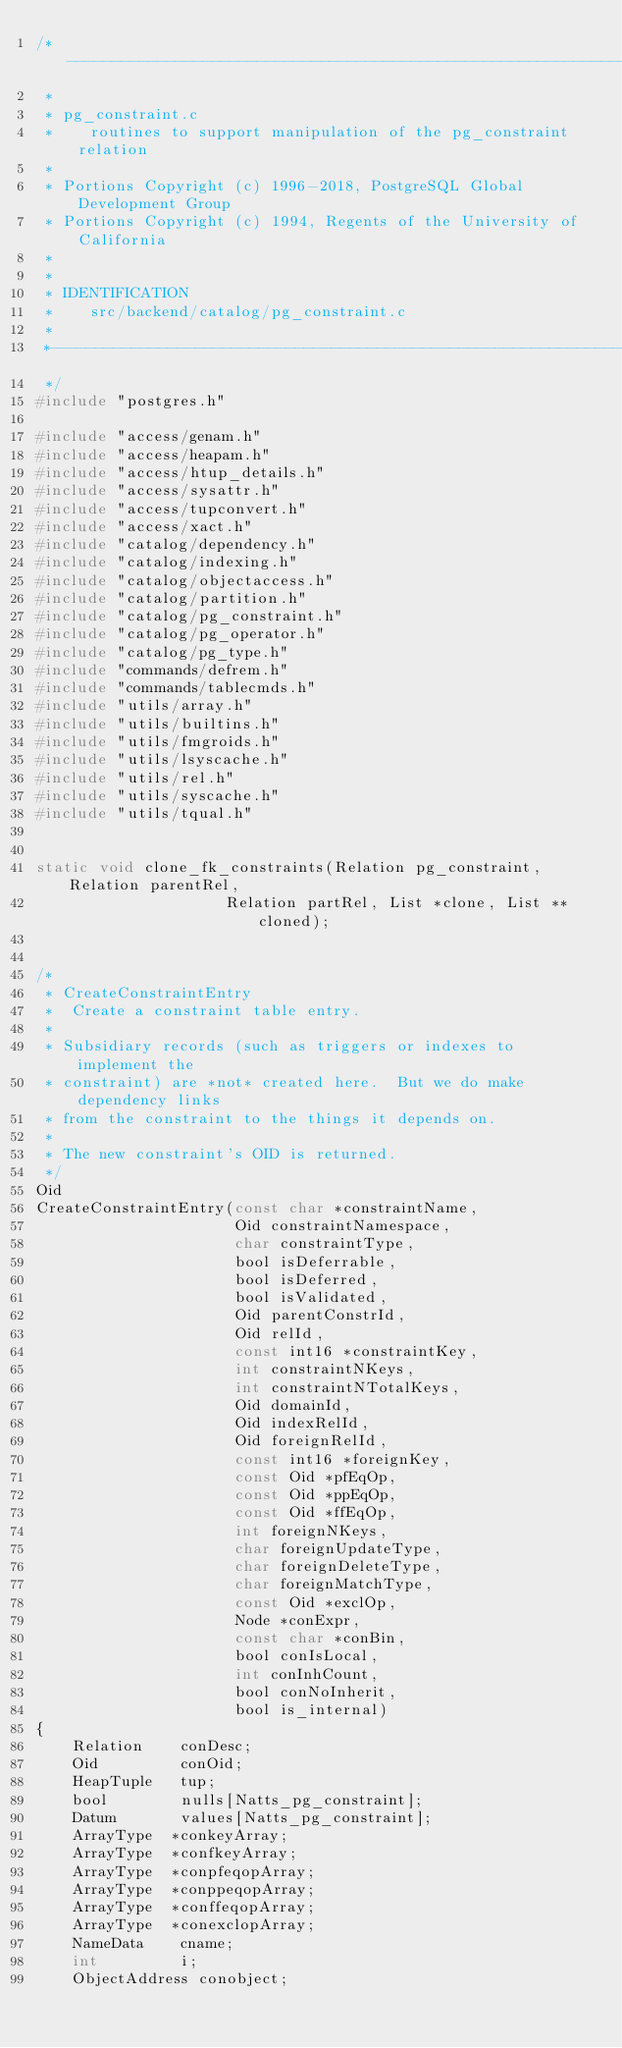<code> <loc_0><loc_0><loc_500><loc_500><_C_>/*-------------------------------------------------------------------------
 *
 * pg_constraint.c
 *	  routines to support manipulation of the pg_constraint relation
 *
 * Portions Copyright (c) 1996-2018, PostgreSQL Global Development Group
 * Portions Copyright (c) 1994, Regents of the University of California
 *
 *
 * IDENTIFICATION
 *	  src/backend/catalog/pg_constraint.c
 *
 *-------------------------------------------------------------------------
 */
#include "postgres.h"

#include "access/genam.h"
#include "access/heapam.h"
#include "access/htup_details.h"
#include "access/sysattr.h"
#include "access/tupconvert.h"
#include "access/xact.h"
#include "catalog/dependency.h"
#include "catalog/indexing.h"
#include "catalog/objectaccess.h"
#include "catalog/partition.h"
#include "catalog/pg_constraint.h"
#include "catalog/pg_operator.h"
#include "catalog/pg_type.h"
#include "commands/defrem.h"
#include "commands/tablecmds.h"
#include "utils/array.h"
#include "utils/builtins.h"
#include "utils/fmgroids.h"
#include "utils/lsyscache.h"
#include "utils/rel.h"
#include "utils/syscache.h"
#include "utils/tqual.h"


static void clone_fk_constraints(Relation pg_constraint, Relation parentRel,
					 Relation partRel, List *clone, List **cloned);


/*
 * CreateConstraintEntry
 *	Create a constraint table entry.
 *
 * Subsidiary records (such as triggers or indexes to implement the
 * constraint) are *not* created here.  But we do make dependency links
 * from the constraint to the things it depends on.
 *
 * The new constraint's OID is returned.
 */
Oid
CreateConstraintEntry(const char *constraintName,
					  Oid constraintNamespace,
					  char constraintType,
					  bool isDeferrable,
					  bool isDeferred,
					  bool isValidated,
					  Oid parentConstrId,
					  Oid relId,
					  const int16 *constraintKey,
					  int constraintNKeys,
					  int constraintNTotalKeys,
					  Oid domainId,
					  Oid indexRelId,
					  Oid foreignRelId,
					  const int16 *foreignKey,
					  const Oid *pfEqOp,
					  const Oid *ppEqOp,
					  const Oid *ffEqOp,
					  int foreignNKeys,
					  char foreignUpdateType,
					  char foreignDeleteType,
					  char foreignMatchType,
					  const Oid *exclOp,
					  Node *conExpr,
					  const char *conBin,
					  bool conIsLocal,
					  int conInhCount,
					  bool conNoInherit,
					  bool is_internal)
{
	Relation	conDesc;
	Oid			conOid;
	HeapTuple	tup;
	bool		nulls[Natts_pg_constraint];
	Datum		values[Natts_pg_constraint];
	ArrayType  *conkeyArray;
	ArrayType  *confkeyArray;
	ArrayType  *conpfeqopArray;
	ArrayType  *conppeqopArray;
	ArrayType  *conffeqopArray;
	ArrayType  *conexclopArray;
	NameData	cname;
	int			i;
	ObjectAddress conobject;
</code> 